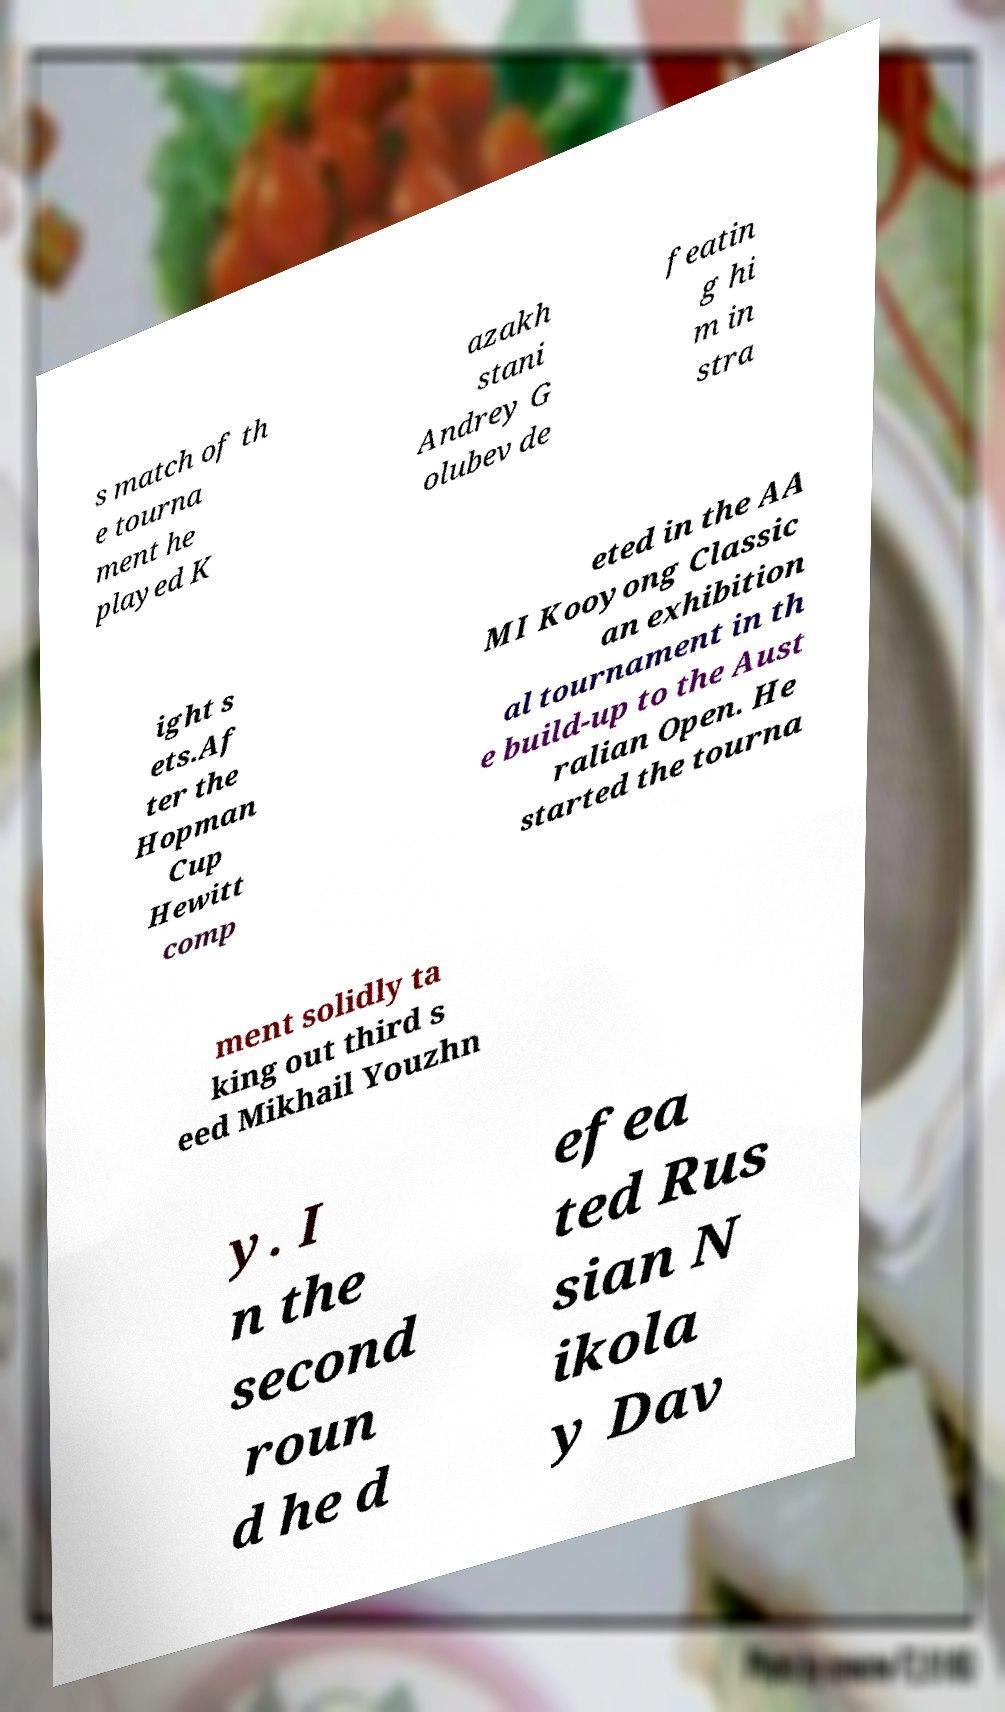Could you assist in decoding the text presented in this image and type it out clearly? s match of th e tourna ment he played K azakh stani Andrey G olubev de featin g hi m in stra ight s ets.Af ter the Hopman Cup Hewitt comp eted in the AA MI Kooyong Classic an exhibition al tournament in th e build-up to the Aust ralian Open. He started the tourna ment solidly ta king out third s eed Mikhail Youzhn y. I n the second roun d he d efea ted Rus sian N ikola y Dav 